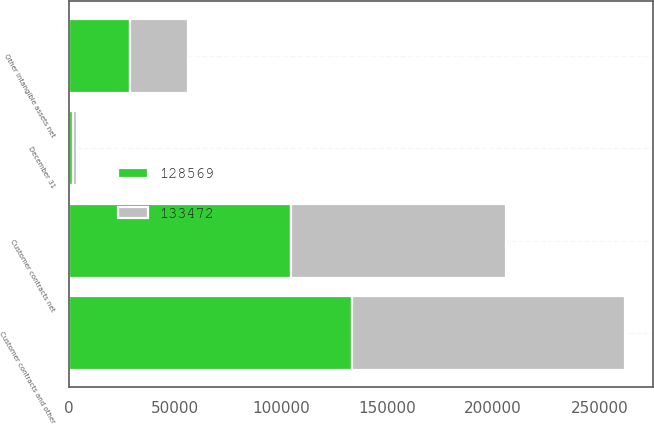Convert chart to OTSL. <chart><loc_0><loc_0><loc_500><loc_500><stacked_bar_chart><ecel><fcel>December 31<fcel>Customer contracts net<fcel>Other intangible assets net<fcel>Customer contracts and other<nl><fcel>128569<fcel>2014<fcel>104657<fcel>28815<fcel>133472<nl><fcel>133472<fcel>2013<fcel>101457<fcel>27112<fcel>128569<nl></chart> 